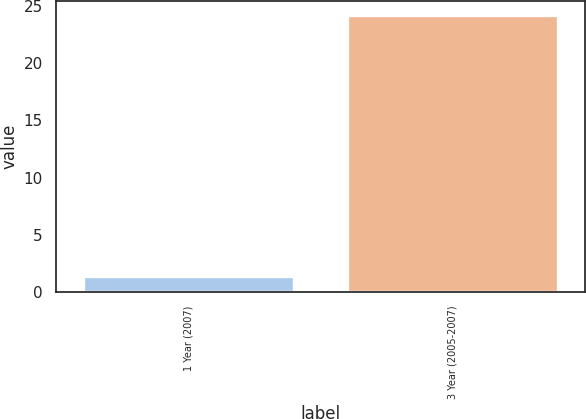Convert chart. <chart><loc_0><loc_0><loc_500><loc_500><bar_chart><fcel>1 Year (2007)<fcel>3 Year (2005-2007)<nl><fcel>1.4<fcel>24.2<nl></chart> 